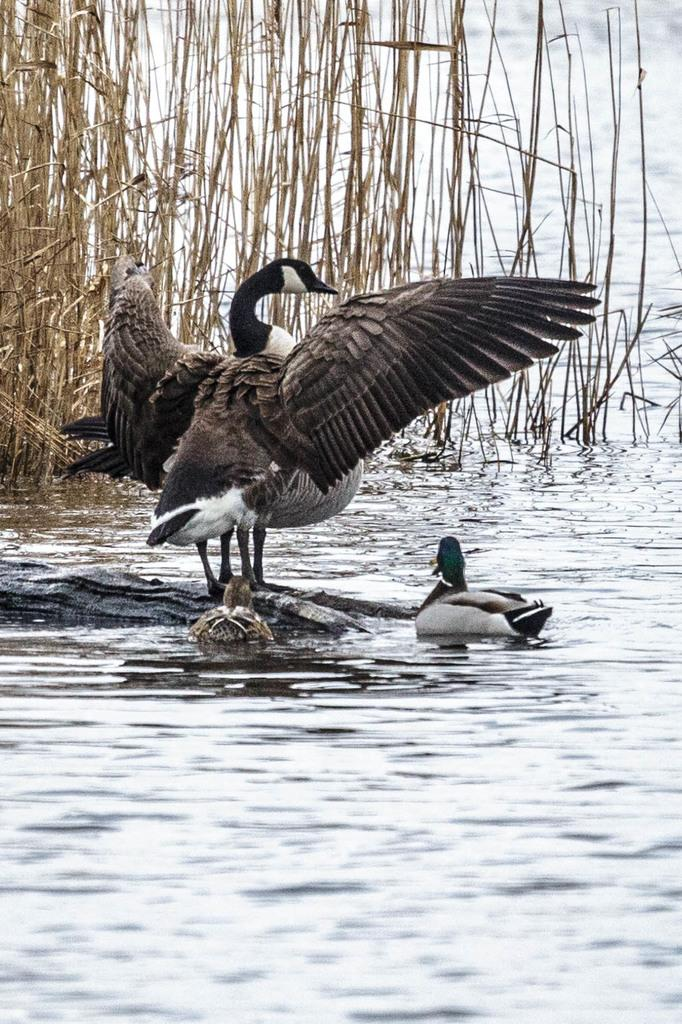What is the bird standing on in the image? The bird is standing on the wooden stem of a tree in the image. Where is the tree located? The tree is in the river. How many birds are in the river? There are two birds in the river. What type of vegetation can be seen in the image? There is dry grass in the image. What type of throne is the bird sitting on in the image? There is no throne present in the image; the bird is standing on the wooden stem of a tree. 